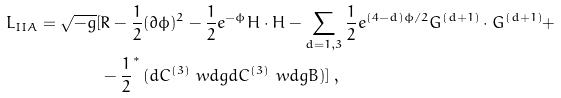Convert formula to latex. <formula><loc_0><loc_0><loc_500><loc_500>L _ { I I A } = \sqrt { - g } [ & R - \frac { 1 } { 2 } ( \partial { \phi } ) ^ { 2 } - \frac { 1 } { 2 } e ^ { - \phi } H \cdot H - \sum _ { d = 1 , 3 } \frac { 1 } { 2 } e ^ { ( 4 - d ) \phi / 2 } G ^ { ( d + 1 ) } \cdot G ^ { ( d + 1 ) } + \\ & - \frac { 1 } { 2 } ^ { * } \, ( d C ^ { ( 3 ) } \ w d g d C ^ { ( 3 ) } \ w d g B ) ] \, ,</formula> 